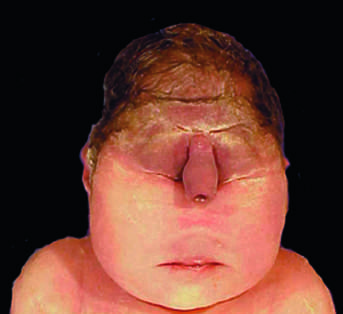s the granuloma in the center associated with a lethal malformation, in which the midface structures are fused or ill-formed?
Answer the question using a single word or phrase. No 